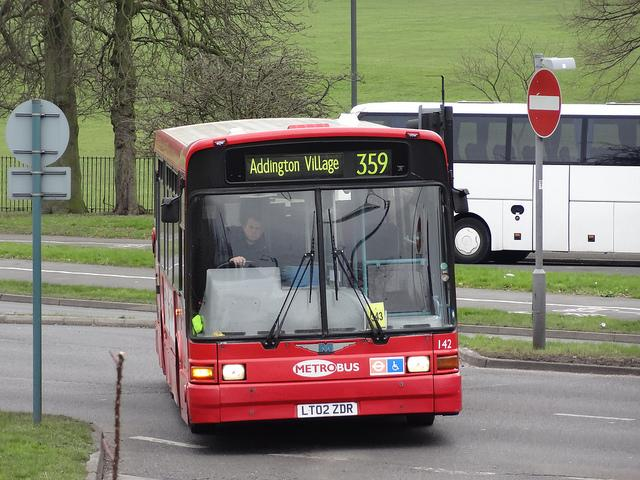What type of information is on the digital bus sign? Please explain your reasoning. informational. The sign is informational. 